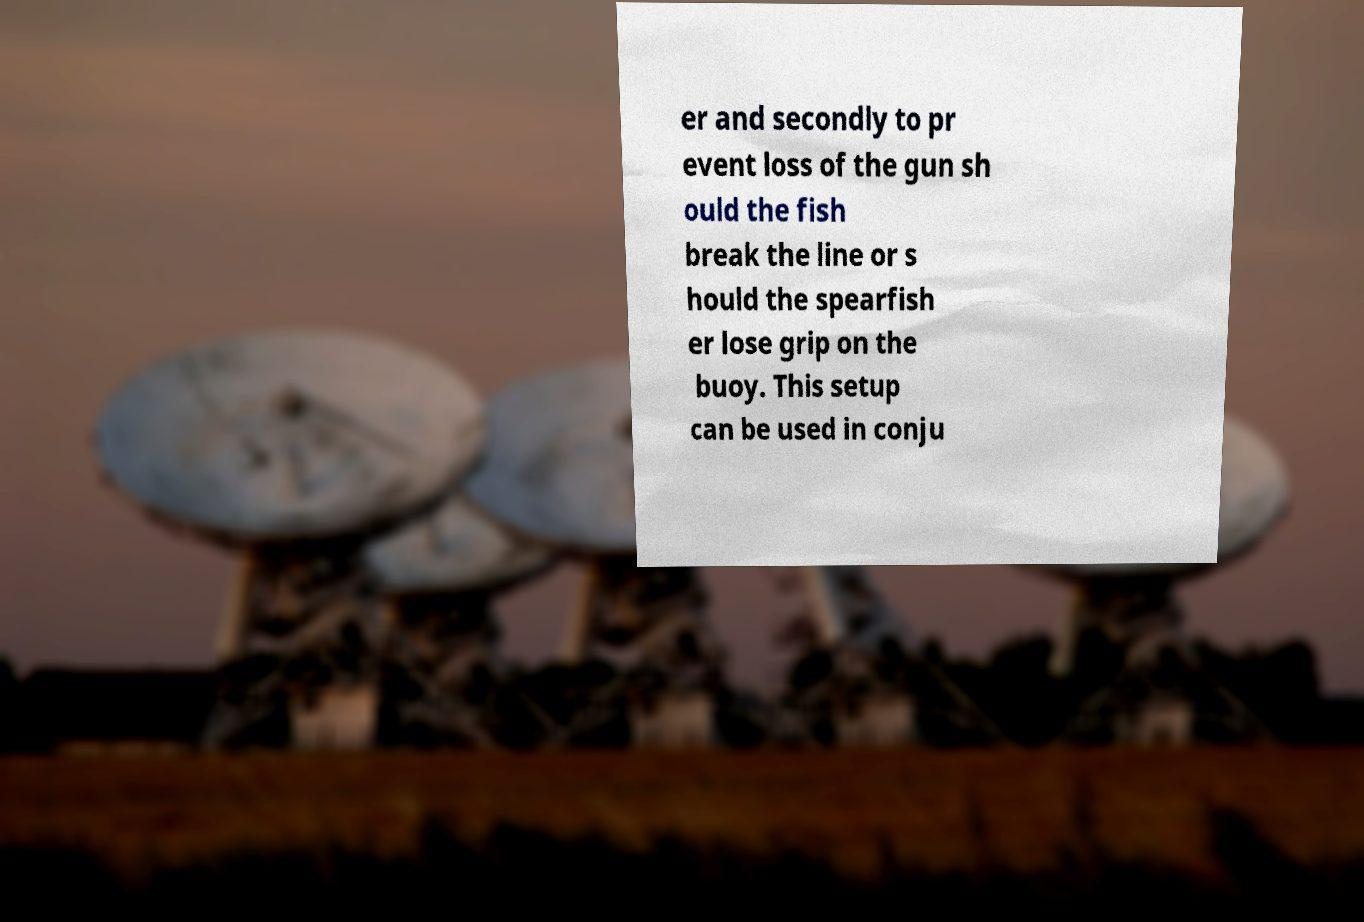Can you read and provide the text displayed in the image?This photo seems to have some interesting text. Can you extract and type it out for me? er and secondly to pr event loss of the gun sh ould the fish break the line or s hould the spearfish er lose grip on the buoy. This setup can be used in conju 